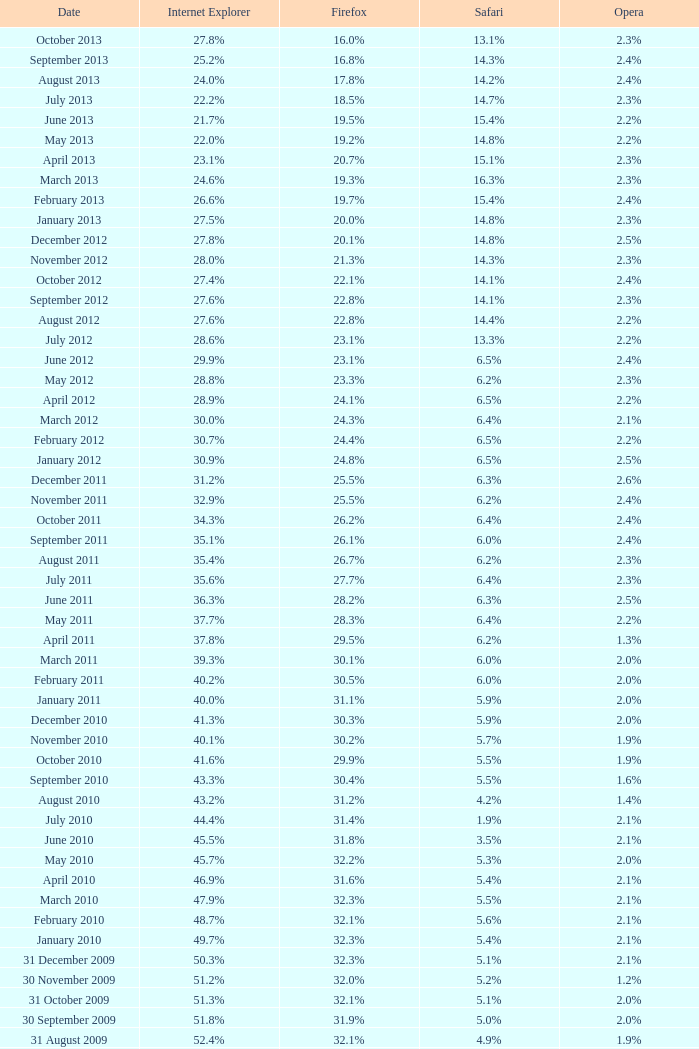What is the safari worth with a 2 14.3%. 